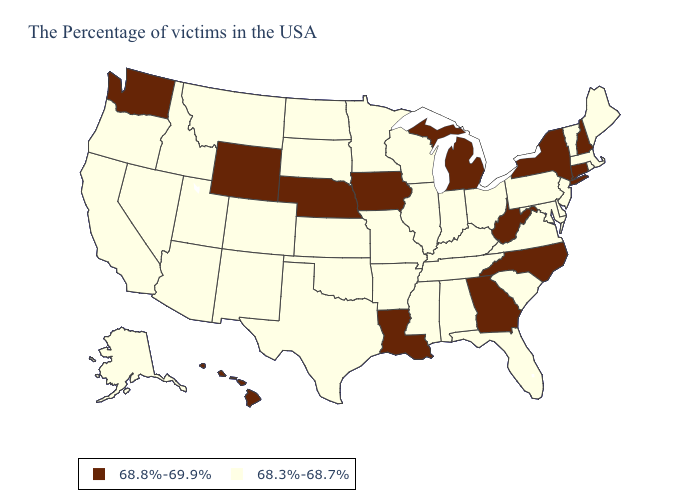Does Connecticut have the lowest value in the USA?
Short answer required. No. Name the states that have a value in the range 68.3%-68.7%?
Give a very brief answer. Maine, Massachusetts, Rhode Island, Vermont, New Jersey, Delaware, Maryland, Pennsylvania, Virginia, South Carolina, Ohio, Florida, Kentucky, Indiana, Alabama, Tennessee, Wisconsin, Illinois, Mississippi, Missouri, Arkansas, Minnesota, Kansas, Oklahoma, Texas, South Dakota, North Dakota, Colorado, New Mexico, Utah, Montana, Arizona, Idaho, Nevada, California, Oregon, Alaska. Among the states that border Alabama , does Georgia have the highest value?
Short answer required. Yes. Does Michigan have the lowest value in the USA?
Give a very brief answer. No. Among the states that border Arkansas , which have the highest value?
Be succinct. Louisiana. Which states have the lowest value in the MidWest?
Give a very brief answer. Ohio, Indiana, Wisconsin, Illinois, Missouri, Minnesota, Kansas, South Dakota, North Dakota. Does New York have the lowest value in the Northeast?
Quick response, please. No. Among the states that border Montana , which have the lowest value?
Give a very brief answer. South Dakota, North Dakota, Idaho. Name the states that have a value in the range 68.8%-69.9%?
Short answer required. New Hampshire, Connecticut, New York, North Carolina, West Virginia, Georgia, Michigan, Louisiana, Iowa, Nebraska, Wyoming, Washington, Hawaii. Name the states that have a value in the range 68.3%-68.7%?
Write a very short answer. Maine, Massachusetts, Rhode Island, Vermont, New Jersey, Delaware, Maryland, Pennsylvania, Virginia, South Carolina, Ohio, Florida, Kentucky, Indiana, Alabama, Tennessee, Wisconsin, Illinois, Mississippi, Missouri, Arkansas, Minnesota, Kansas, Oklahoma, Texas, South Dakota, North Dakota, Colorado, New Mexico, Utah, Montana, Arizona, Idaho, Nevada, California, Oregon, Alaska. What is the highest value in the USA?
Answer briefly. 68.8%-69.9%. What is the lowest value in states that border New Hampshire?
Short answer required. 68.3%-68.7%. Does Iowa have the lowest value in the USA?
Short answer required. No. What is the highest value in the MidWest ?
Answer briefly. 68.8%-69.9%. 